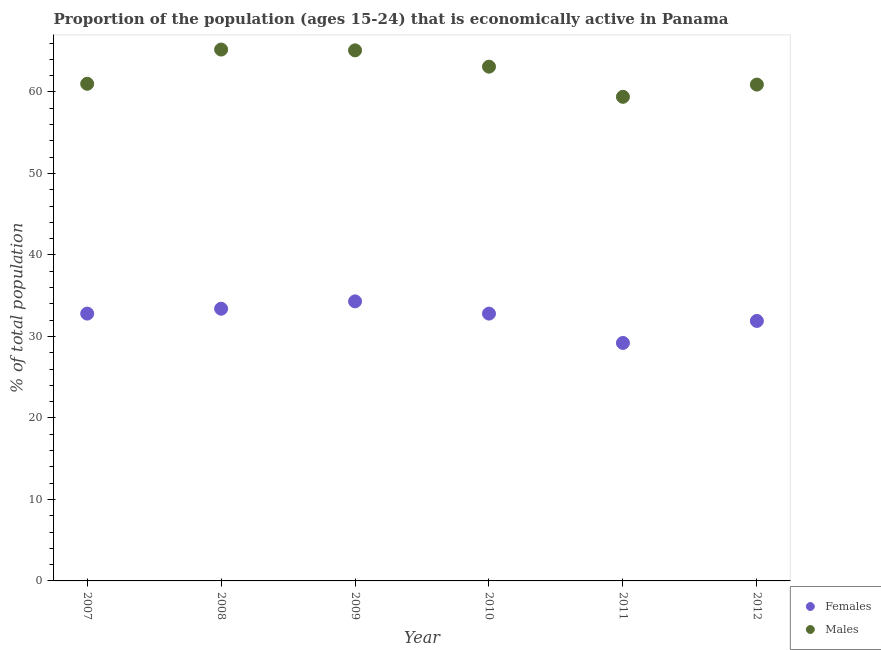How many different coloured dotlines are there?
Give a very brief answer. 2. What is the percentage of economically active female population in 2007?
Provide a succinct answer. 32.8. Across all years, what is the maximum percentage of economically active female population?
Make the answer very short. 34.3. Across all years, what is the minimum percentage of economically active female population?
Ensure brevity in your answer.  29.2. In which year was the percentage of economically active female population minimum?
Keep it short and to the point. 2011. What is the total percentage of economically active male population in the graph?
Provide a short and direct response. 374.7. What is the difference between the percentage of economically active male population in 2007 and that in 2008?
Make the answer very short. -4.2. What is the difference between the percentage of economically active female population in 2010 and the percentage of economically active male population in 2009?
Offer a very short reply. -32.3. What is the average percentage of economically active male population per year?
Ensure brevity in your answer.  62.45. In the year 2010, what is the difference between the percentage of economically active female population and percentage of economically active male population?
Your answer should be compact. -30.3. In how many years, is the percentage of economically active male population greater than 64 %?
Offer a terse response. 2. What is the ratio of the percentage of economically active female population in 2010 to that in 2012?
Your answer should be compact. 1.03. Is the percentage of economically active female population in 2008 less than that in 2010?
Give a very brief answer. No. Is the difference between the percentage of economically active female population in 2009 and 2011 greater than the difference between the percentage of economically active male population in 2009 and 2011?
Your answer should be compact. No. What is the difference between the highest and the second highest percentage of economically active male population?
Keep it short and to the point. 0.1. What is the difference between the highest and the lowest percentage of economically active female population?
Offer a very short reply. 5.1. In how many years, is the percentage of economically active male population greater than the average percentage of economically active male population taken over all years?
Your response must be concise. 3. Is the percentage of economically active male population strictly less than the percentage of economically active female population over the years?
Offer a very short reply. No. How many dotlines are there?
Offer a very short reply. 2. What is the difference between two consecutive major ticks on the Y-axis?
Your answer should be very brief. 10. Does the graph contain any zero values?
Ensure brevity in your answer.  No. Does the graph contain grids?
Provide a succinct answer. No. How many legend labels are there?
Offer a terse response. 2. What is the title of the graph?
Provide a succinct answer. Proportion of the population (ages 15-24) that is economically active in Panama. What is the label or title of the X-axis?
Your response must be concise. Year. What is the label or title of the Y-axis?
Keep it short and to the point. % of total population. What is the % of total population in Females in 2007?
Offer a very short reply. 32.8. What is the % of total population in Males in 2007?
Keep it short and to the point. 61. What is the % of total population in Females in 2008?
Provide a short and direct response. 33.4. What is the % of total population of Males in 2008?
Your response must be concise. 65.2. What is the % of total population of Females in 2009?
Give a very brief answer. 34.3. What is the % of total population in Males in 2009?
Give a very brief answer. 65.1. What is the % of total population of Females in 2010?
Offer a terse response. 32.8. What is the % of total population of Males in 2010?
Your answer should be very brief. 63.1. What is the % of total population of Females in 2011?
Offer a terse response. 29.2. What is the % of total population in Males in 2011?
Your answer should be compact. 59.4. What is the % of total population of Females in 2012?
Ensure brevity in your answer.  31.9. What is the % of total population in Males in 2012?
Your answer should be very brief. 60.9. Across all years, what is the maximum % of total population in Females?
Provide a succinct answer. 34.3. Across all years, what is the maximum % of total population in Males?
Offer a very short reply. 65.2. Across all years, what is the minimum % of total population in Females?
Give a very brief answer. 29.2. Across all years, what is the minimum % of total population in Males?
Make the answer very short. 59.4. What is the total % of total population in Females in the graph?
Give a very brief answer. 194.4. What is the total % of total population in Males in the graph?
Provide a succinct answer. 374.7. What is the difference between the % of total population in Males in 2007 and that in 2008?
Your answer should be very brief. -4.2. What is the difference between the % of total population in Females in 2007 and that in 2009?
Make the answer very short. -1.5. What is the difference between the % of total population in Females in 2007 and that in 2010?
Ensure brevity in your answer.  0. What is the difference between the % of total population in Males in 2007 and that in 2010?
Provide a succinct answer. -2.1. What is the difference between the % of total population in Males in 2007 and that in 2011?
Your answer should be compact. 1.6. What is the difference between the % of total population of Females in 2007 and that in 2012?
Your answer should be very brief. 0.9. What is the difference between the % of total population of Males in 2007 and that in 2012?
Ensure brevity in your answer.  0.1. What is the difference between the % of total population in Males in 2008 and that in 2010?
Your answer should be compact. 2.1. What is the difference between the % of total population in Females in 2008 and that in 2011?
Your answer should be very brief. 4.2. What is the difference between the % of total population in Females in 2008 and that in 2012?
Give a very brief answer. 1.5. What is the difference between the % of total population of Males in 2008 and that in 2012?
Offer a terse response. 4.3. What is the difference between the % of total population in Females in 2009 and that in 2010?
Make the answer very short. 1.5. What is the difference between the % of total population in Females in 2009 and that in 2012?
Ensure brevity in your answer.  2.4. What is the difference between the % of total population in Males in 2009 and that in 2012?
Offer a very short reply. 4.2. What is the difference between the % of total population in Females in 2010 and that in 2011?
Your answer should be very brief. 3.6. What is the difference between the % of total population in Males in 2010 and that in 2011?
Make the answer very short. 3.7. What is the difference between the % of total population of Males in 2011 and that in 2012?
Ensure brevity in your answer.  -1.5. What is the difference between the % of total population of Females in 2007 and the % of total population of Males in 2008?
Offer a terse response. -32.4. What is the difference between the % of total population of Females in 2007 and the % of total population of Males in 2009?
Provide a succinct answer. -32.3. What is the difference between the % of total population in Females in 2007 and the % of total population in Males in 2010?
Provide a short and direct response. -30.3. What is the difference between the % of total population of Females in 2007 and the % of total population of Males in 2011?
Make the answer very short. -26.6. What is the difference between the % of total population of Females in 2007 and the % of total population of Males in 2012?
Your answer should be compact. -28.1. What is the difference between the % of total population in Females in 2008 and the % of total population in Males in 2009?
Ensure brevity in your answer.  -31.7. What is the difference between the % of total population of Females in 2008 and the % of total population of Males in 2010?
Make the answer very short. -29.7. What is the difference between the % of total population in Females in 2008 and the % of total population in Males in 2012?
Offer a very short reply. -27.5. What is the difference between the % of total population in Females in 2009 and the % of total population in Males in 2010?
Offer a very short reply. -28.8. What is the difference between the % of total population of Females in 2009 and the % of total population of Males in 2011?
Provide a succinct answer. -25.1. What is the difference between the % of total population in Females in 2009 and the % of total population in Males in 2012?
Keep it short and to the point. -26.6. What is the difference between the % of total population of Females in 2010 and the % of total population of Males in 2011?
Provide a short and direct response. -26.6. What is the difference between the % of total population in Females in 2010 and the % of total population in Males in 2012?
Your response must be concise. -28.1. What is the difference between the % of total population in Females in 2011 and the % of total population in Males in 2012?
Offer a terse response. -31.7. What is the average % of total population of Females per year?
Your answer should be very brief. 32.4. What is the average % of total population of Males per year?
Provide a succinct answer. 62.45. In the year 2007, what is the difference between the % of total population of Females and % of total population of Males?
Your response must be concise. -28.2. In the year 2008, what is the difference between the % of total population in Females and % of total population in Males?
Make the answer very short. -31.8. In the year 2009, what is the difference between the % of total population of Females and % of total population of Males?
Ensure brevity in your answer.  -30.8. In the year 2010, what is the difference between the % of total population in Females and % of total population in Males?
Provide a short and direct response. -30.3. In the year 2011, what is the difference between the % of total population of Females and % of total population of Males?
Offer a terse response. -30.2. What is the ratio of the % of total population of Females in 2007 to that in 2008?
Provide a succinct answer. 0.98. What is the ratio of the % of total population in Males in 2007 to that in 2008?
Your answer should be very brief. 0.94. What is the ratio of the % of total population in Females in 2007 to that in 2009?
Keep it short and to the point. 0.96. What is the ratio of the % of total population of Males in 2007 to that in 2009?
Ensure brevity in your answer.  0.94. What is the ratio of the % of total population of Females in 2007 to that in 2010?
Offer a very short reply. 1. What is the ratio of the % of total population of Males in 2007 to that in 2010?
Your answer should be very brief. 0.97. What is the ratio of the % of total population of Females in 2007 to that in 2011?
Give a very brief answer. 1.12. What is the ratio of the % of total population of Males in 2007 to that in 2011?
Make the answer very short. 1.03. What is the ratio of the % of total population in Females in 2007 to that in 2012?
Provide a short and direct response. 1.03. What is the ratio of the % of total population of Females in 2008 to that in 2009?
Give a very brief answer. 0.97. What is the ratio of the % of total population in Males in 2008 to that in 2009?
Provide a succinct answer. 1. What is the ratio of the % of total population in Females in 2008 to that in 2010?
Your response must be concise. 1.02. What is the ratio of the % of total population of Females in 2008 to that in 2011?
Keep it short and to the point. 1.14. What is the ratio of the % of total population of Males in 2008 to that in 2011?
Your answer should be compact. 1.1. What is the ratio of the % of total population of Females in 2008 to that in 2012?
Keep it short and to the point. 1.05. What is the ratio of the % of total population in Males in 2008 to that in 2012?
Keep it short and to the point. 1.07. What is the ratio of the % of total population of Females in 2009 to that in 2010?
Give a very brief answer. 1.05. What is the ratio of the % of total population of Males in 2009 to that in 2010?
Keep it short and to the point. 1.03. What is the ratio of the % of total population in Females in 2009 to that in 2011?
Keep it short and to the point. 1.17. What is the ratio of the % of total population of Males in 2009 to that in 2011?
Make the answer very short. 1.1. What is the ratio of the % of total population in Females in 2009 to that in 2012?
Give a very brief answer. 1.08. What is the ratio of the % of total population in Males in 2009 to that in 2012?
Keep it short and to the point. 1.07. What is the ratio of the % of total population in Females in 2010 to that in 2011?
Give a very brief answer. 1.12. What is the ratio of the % of total population in Males in 2010 to that in 2011?
Give a very brief answer. 1.06. What is the ratio of the % of total population in Females in 2010 to that in 2012?
Offer a very short reply. 1.03. What is the ratio of the % of total population of Males in 2010 to that in 2012?
Provide a succinct answer. 1.04. What is the ratio of the % of total population in Females in 2011 to that in 2012?
Provide a succinct answer. 0.92. What is the ratio of the % of total population in Males in 2011 to that in 2012?
Offer a very short reply. 0.98. What is the difference between the highest and the second highest % of total population in Females?
Provide a succinct answer. 0.9. What is the difference between the highest and the second highest % of total population of Males?
Offer a terse response. 0.1. 